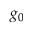<formula> <loc_0><loc_0><loc_500><loc_500>g _ { 0 }</formula> 